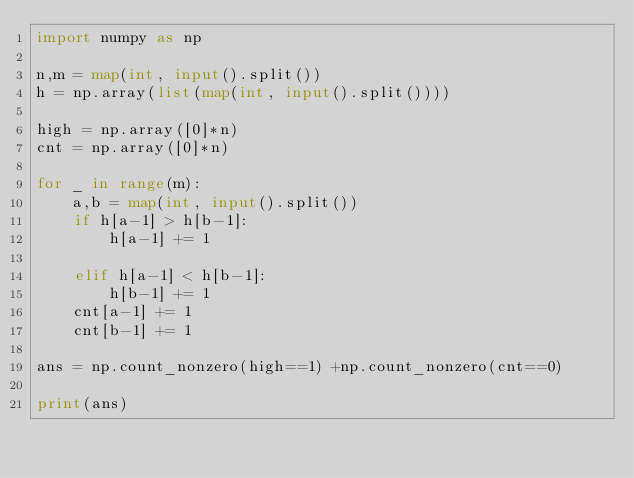<code> <loc_0><loc_0><loc_500><loc_500><_Python_>import numpy as np

n,m = map(int, input().split())
h = np.array(list(map(int, input().split())))

high = np.array([0]*n)
cnt = np.array([0]*n)

for _ in range(m):
    a,b = map(int, input().split())
    if h[a-1] > h[b-1]:
        h[a-1] += 1
    
    elif h[a-1] < h[b-1]:
        h[b-1] += 1
    cnt[a-1] += 1
    cnt[b-1] += 1

ans = np.count_nonzero(high==1) +np.count_nonzero(cnt==0)

print(ans)</code> 